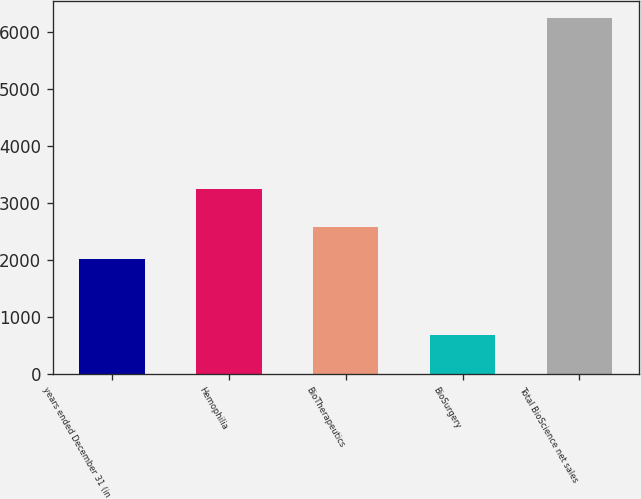Convert chart. <chart><loc_0><loc_0><loc_500><loc_500><bar_chart><fcel>years ended December 31 (in<fcel>Hemophilia<fcel>BioTherapeutics<fcel>BioSurgery<fcel>Total BioScience net sales<nl><fcel>2012<fcel>3241<fcel>2568.4<fcel>673<fcel>6237<nl></chart> 